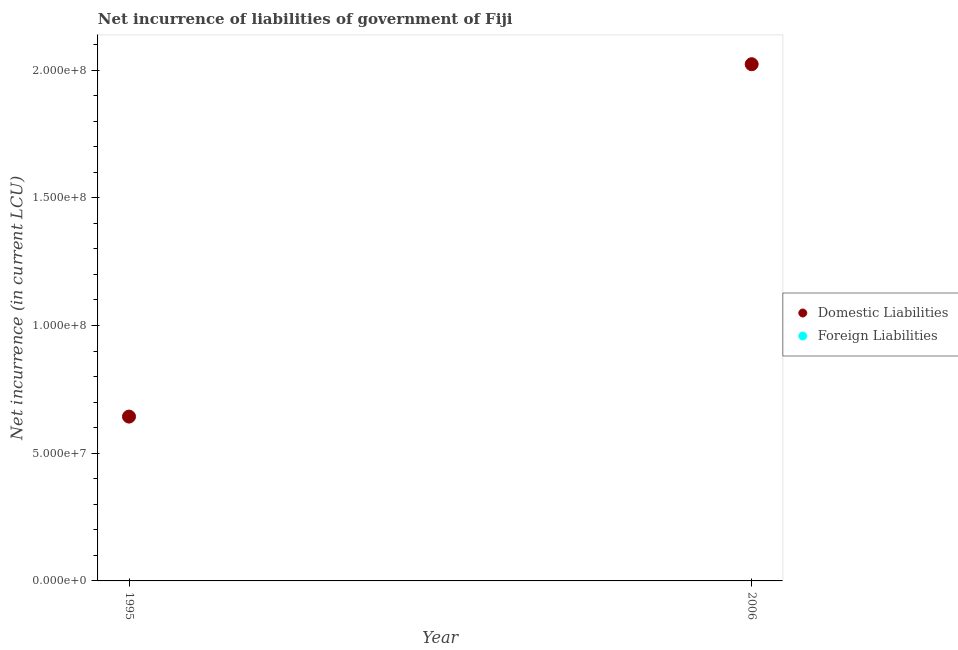What is the net incurrence of domestic liabilities in 2006?
Make the answer very short. 2.02e+08. Across all years, what is the maximum net incurrence of domestic liabilities?
Offer a terse response. 2.02e+08. Across all years, what is the minimum net incurrence of domestic liabilities?
Ensure brevity in your answer.  6.43e+07. In which year was the net incurrence of domestic liabilities maximum?
Offer a terse response. 2006. What is the total net incurrence of domestic liabilities in the graph?
Provide a short and direct response. 2.67e+08. What is the difference between the net incurrence of domestic liabilities in 1995 and that in 2006?
Offer a terse response. -1.38e+08. What is the difference between the net incurrence of domestic liabilities in 2006 and the net incurrence of foreign liabilities in 1995?
Your answer should be very brief. 2.02e+08. What is the average net incurrence of domestic liabilities per year?
Your answer should be compact. 1.33e+08. In how many years, is the net incurrence of domestic liabilities greater than 130000000 LCU?
Your answer should be compact. 1. What is the ratio of the net incurrence of domestic liabilities in 1995 to that in 2006?
Keep it short and to the point. 0.32. Does the net incurrence of domestic liabilities monotonically increase over the years?
Keep it short and to the point. Yes. Is the net incurrence of foreign liabilities strictly greater than the net incurrence of domestic liabilities over the years?
Your answer should be very brief. No. What is the difference between two consecutive major ticks on the Y-axis?
Provide a succinct answer. 5.00e+07. Does the graph contain grids?
Your response must be concise. No. Where does the legend appear in the graph?
Make the answer very short. Center right. How are the legend labels stacked?
Give a very brief answer. Vertical. What is the title of the graph?
Offer a very short reply. Net incurrence of liabilities of government of Fiji. What is the label or title of the Y-axis?
Offer a terse response. Net incurrence (in current LCU). What is the Net incurrence (in current LCU) in Domestic Liabilities in 1995?
Your answer should be very brief. 6.43e+07. What is the Net incurrence (in current LCU) of Foreign Liabilities in 1995?
Make the answer very short. 0. What is the Net incurrence (in current LCU) in Domestic Liabilities in 2006?
Give a very brief answer. 2.02e+08. Across all years, what is the maximum Net incurrence (in current LCU) of Domestic Liabilities?
Your response must be concise. 2.02e+08. Across all years, what is the minimum Net incurrence (in current LCU) of Domestic Liabilities?
Give a very brief answer. 6.43e+07. What is the total Net incurrence (in current LCU) in Domestic Liabilities in the graph?
Make the answer very short. 2.67e+08. What is the difference between the Net incurrence (in current LCU) of Domestic Liabilities in 1995 and that in 2006?
Offer a very short reply. -1.38e+08. What is the average Net incurrence (in current LCU) in Domestic Liabilities per year?
Offer a very short reply. 1.33e+08. What is the ratio of the Net incurrence (in current LCU) of Domestic Liabilities in 1995 to that in 2006?
Keep it short and to the point. 0.32. What is the difference between the highest and the second highest Net incurrence (in current LCU) in Domestic Liabilities?
Give a very brief answer. 1.38e+08. What is the difference between the highest and the lowest Net incurrence (in current LCU) in Domestic Liabilities?
Your answer should be compact. 1.38e+08. 